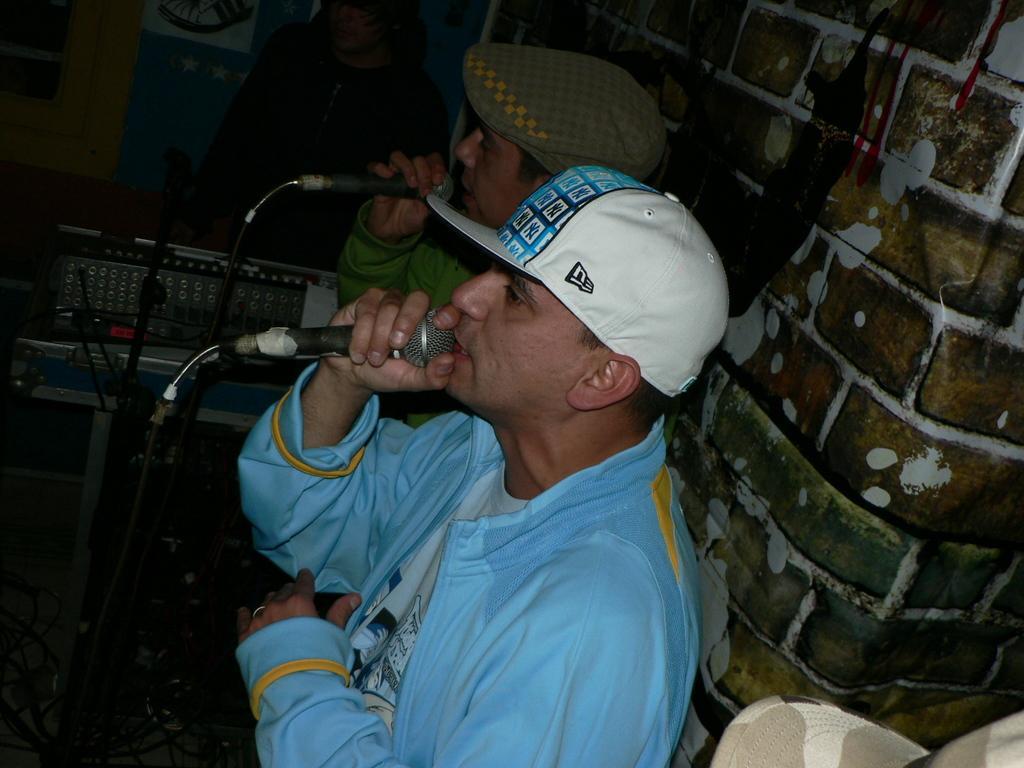Can you describe this image briefly? In this image I can see two persons standing in front of the microphones. In front the person is wearing blue and white color dress. In the background the wall is in brown and white color. 